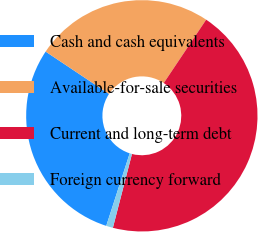<chart> <loc_0><loc_0><loc_500><loc_500><pie_chart><fcel>Cash and cash equivalents<fcel>Available-for-sale securities<fcel>Current and long-term debt<fcel>Foreign currency forward<nl><fcel>29.39%<fcel>25.02%<fcel>44.64%<fcel>0.95%<nl></chart> 